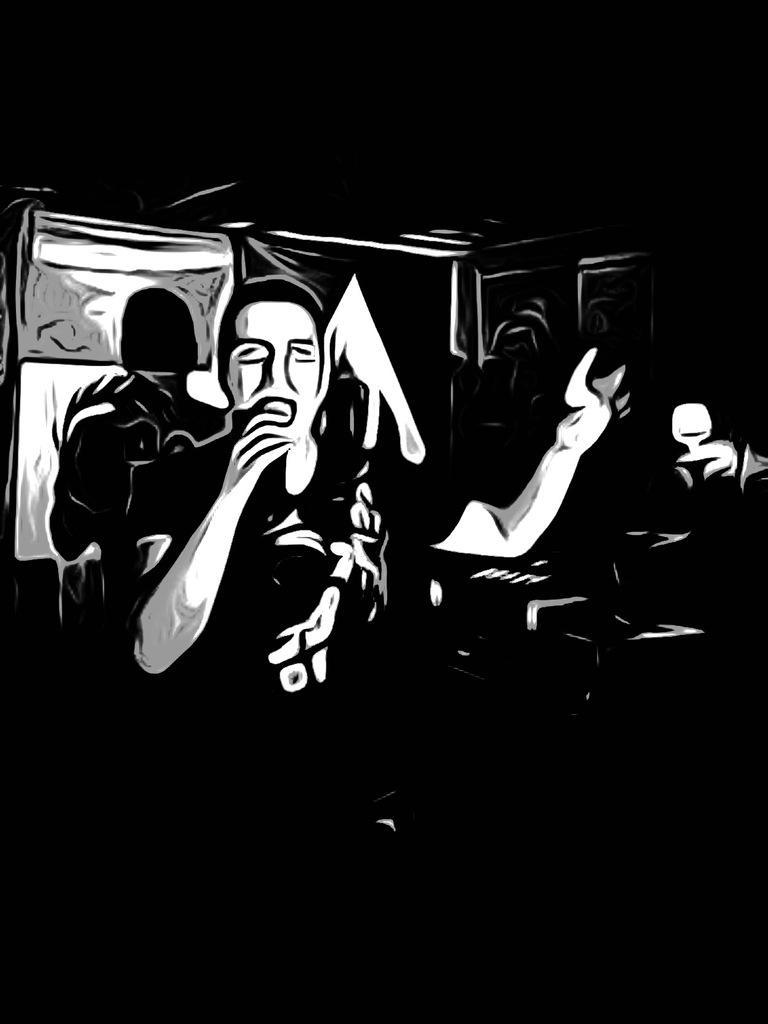Could you give a brief overview of what you see in this image? This is a cartoon image of a person and some other things. This picture is black and white in color. 